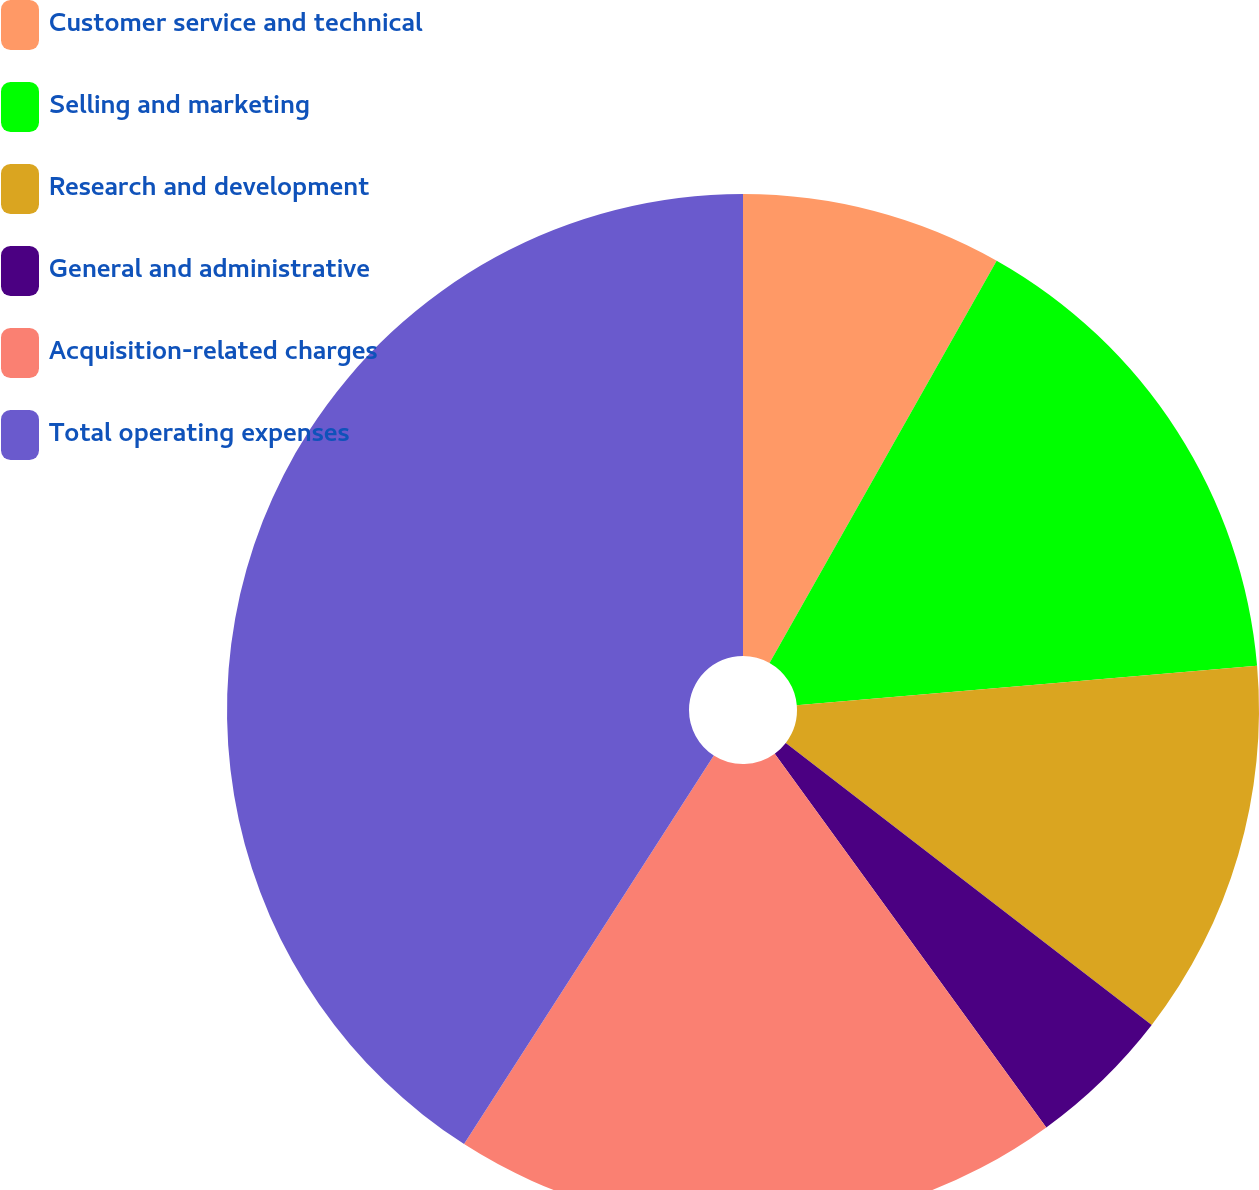Convert chart to OTSL. <chart><loc_0><loc_0><loc_500><loc_500><pie_chart><fcel>Customer service and technical<fcel>Selling and marketing<fcel>Research and development<fcel>General and administrative<fcel>Acquisition-related charges<fcel>Total operating expenses<nl><fcel>8.18%<fcel>15.45%<fcel>11.82%<fcel>4.55%<fcel>19.09%<fcel>40.91%<nl></chart> 